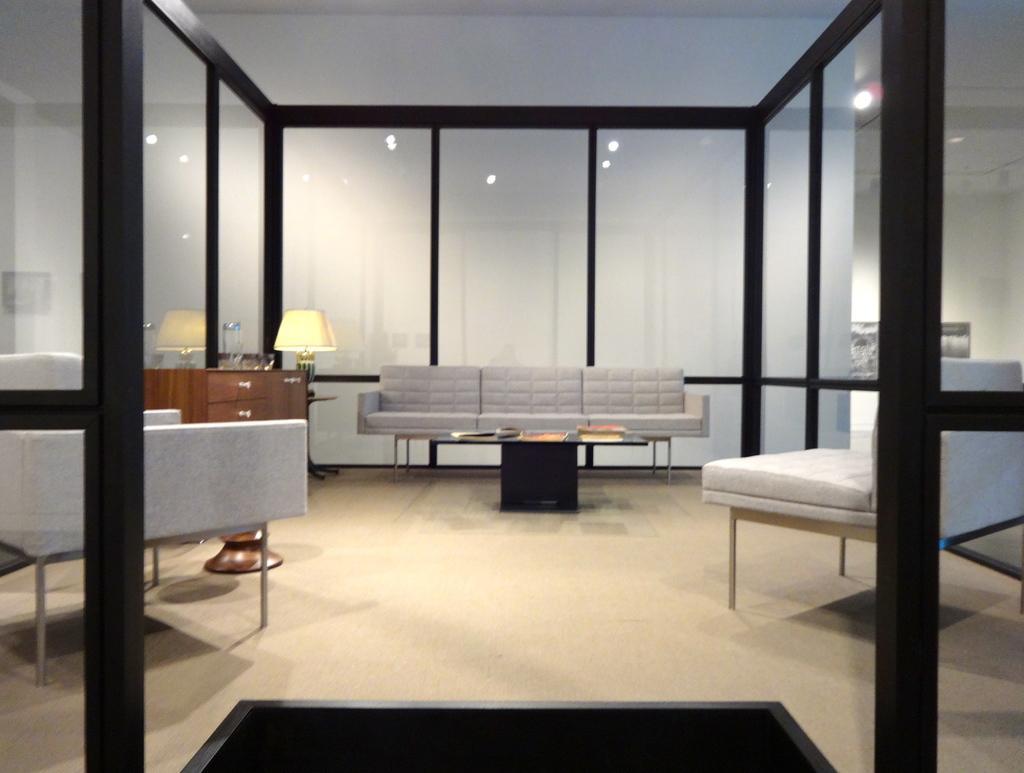Describe this image in one or two sentences. In this picture we can see room with sofa beside to that table, lamp, racks and we can see glass wall. 